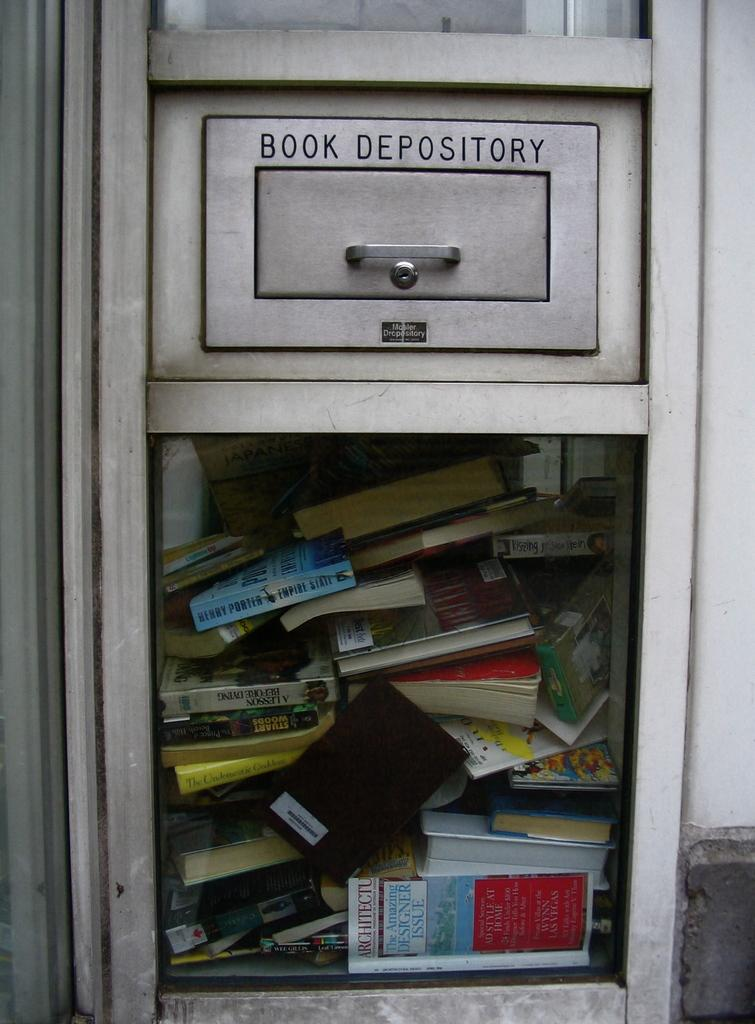<image>
Relay a brief, clear account of the picture shown. A book depository slot with a see through window the inside has books packed full. 